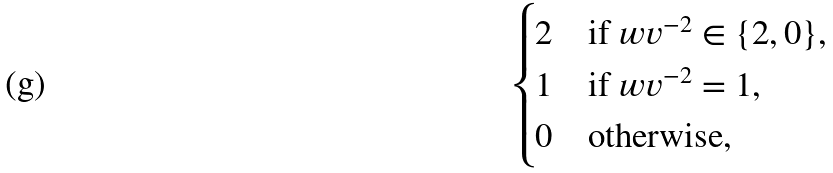Convert formula to latex. <formula><loc_0><loc_0><loc_500><loc_500>\begin{cases} 2 & \text {if } w v ^ { - 2 } \in \{ 2 , 0 \} , \\ 1 & \text {if } w v ^ { - 2 } = 1 , \\ 0 & \text {otherwise} , \end{cases}</formula> 